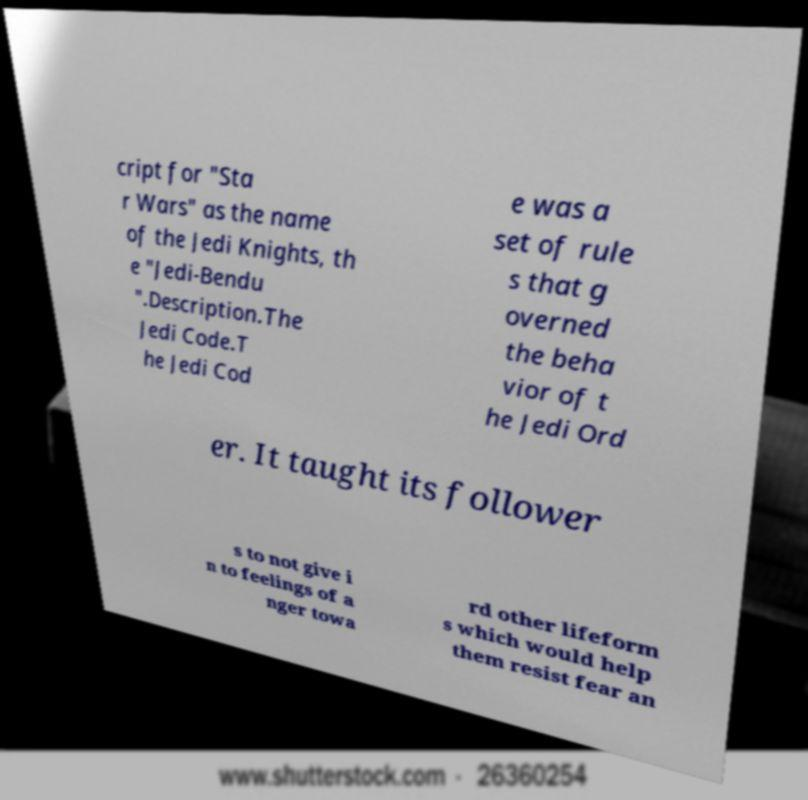What messages or text are displayed in this image? I need them in a readable, typed format. cript for "Sta r Wars" as the name of the Jedi Knights, th e "Jedi-Bendu ".Description.The Jedi Code.T he Jedi Cod e was a set of rule s that g overned the beha vior of t he Jedi Ord er. It taught its follower s to not give i n to feelings of a nger towa rd other lifeform s which would help them resist fear an 